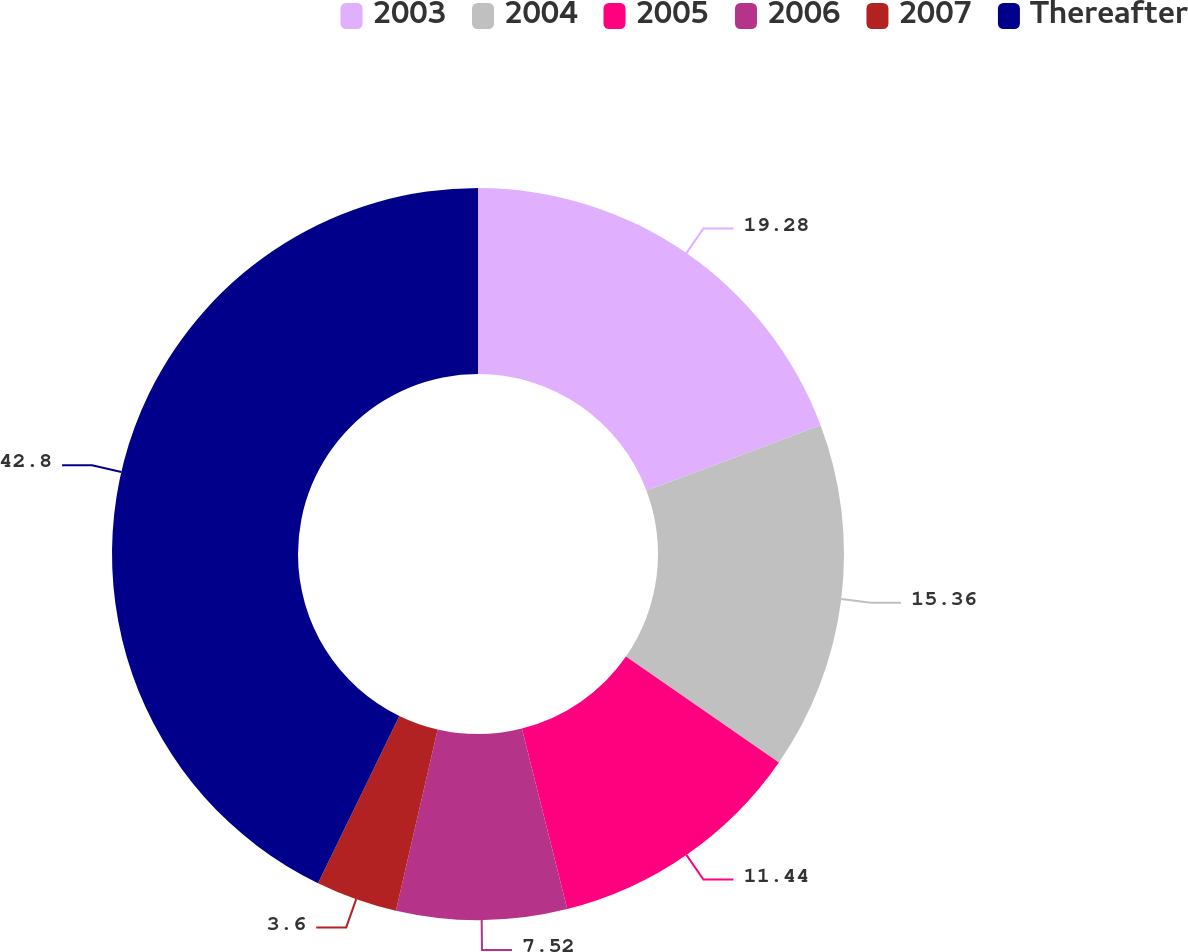Convert chart to OTSL. <chart><loc_0><loc_0><loc_500><loc_500><pie_chart><fcel>2003<fcel>2004<fcel>2005<fcel>2006<fcel>2007<fcel>Thereafter<nl><fcel>19.28%<fcel>15.36%<fcel>11.44%<fcel>7.52%<fcel>3.6%<fcel>42.8%<nl></chart> 